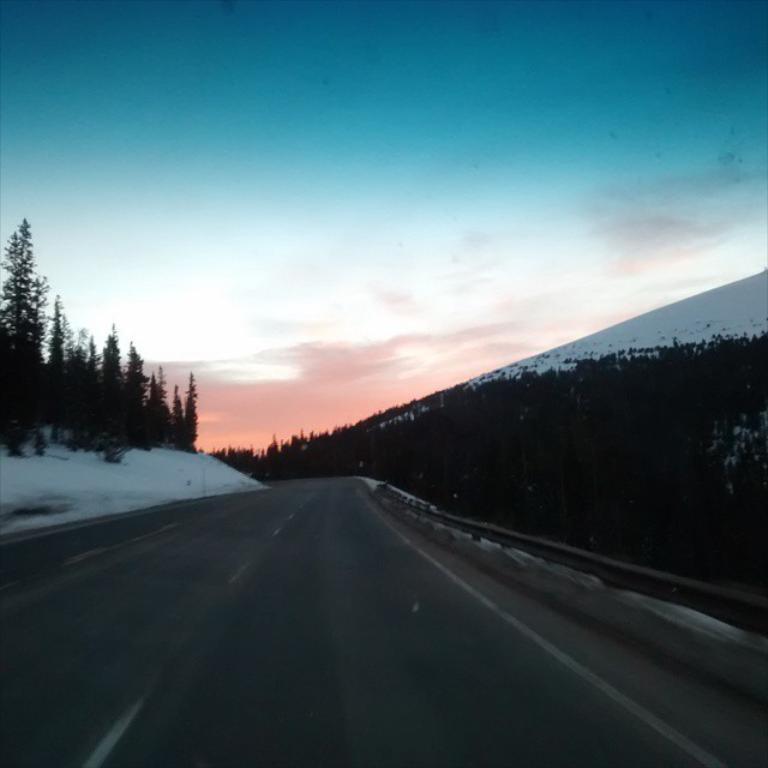Could you give a brief overview of what you see in this image? At the bottom of the image there is road. Behind the road there is snow and fencing and trees and hills. At the top of the image there are some clouds in the sky. 